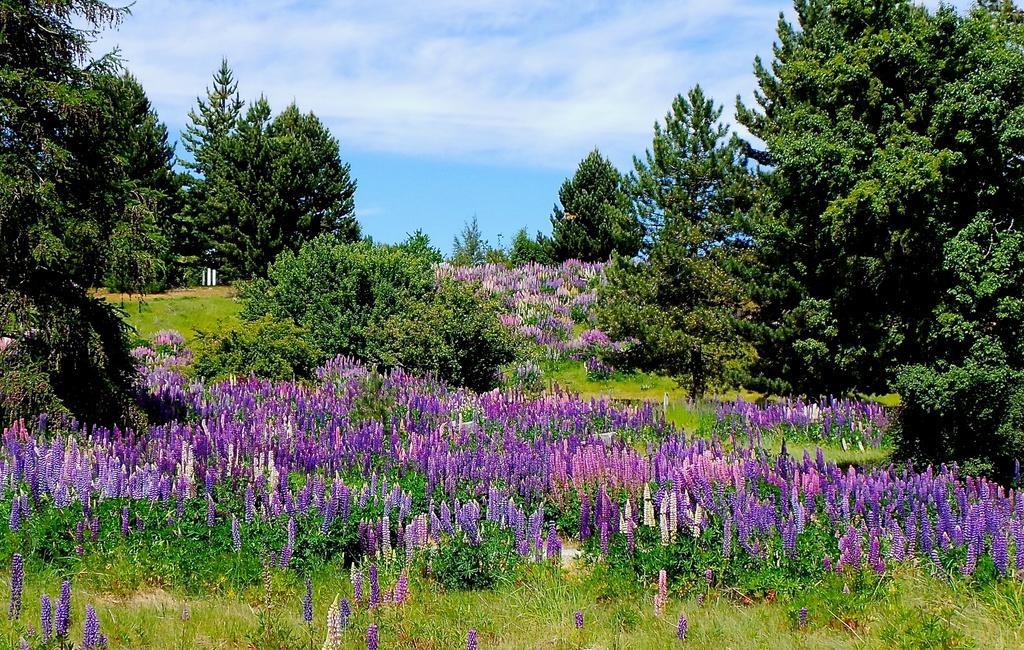Can you describe this image briefly? In the foreground of this image, there are flowers to the plants and trees. At the top, there is the sky and the cloud. 